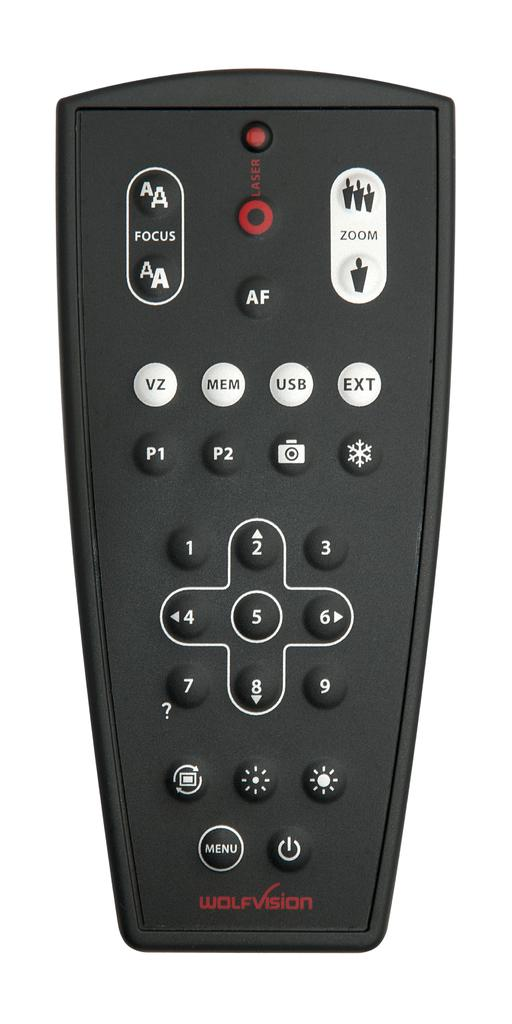<image>
Relay a brief, clear account of the picture shown. A black remote control by wolfvision showing various commands and menus. 